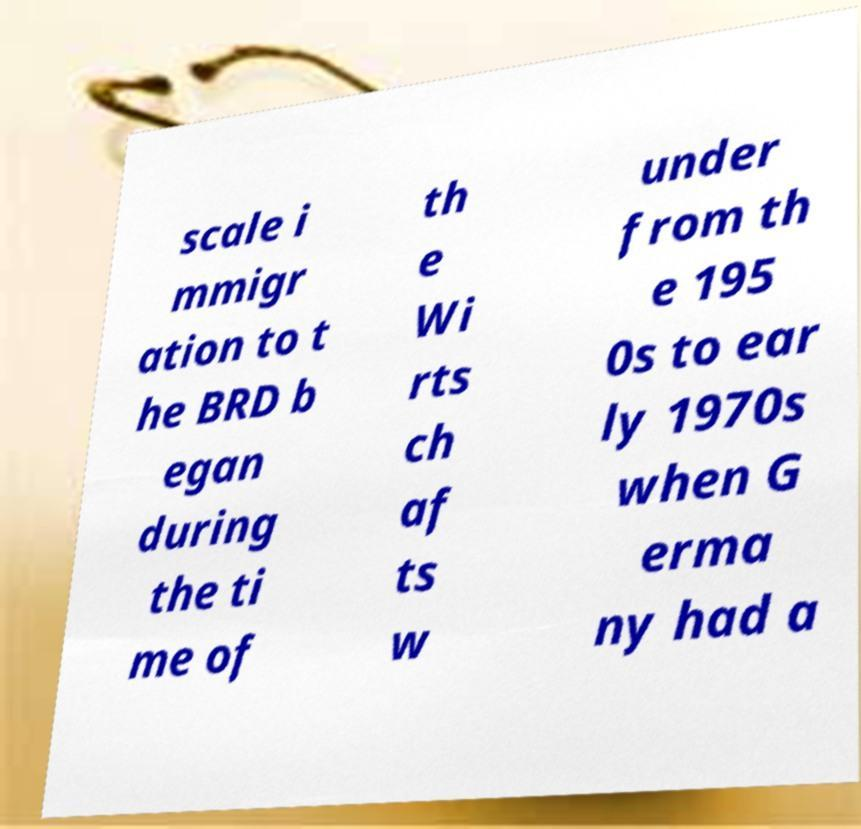Please identify and transcribe the text found in this image. scale i mmigr ation to t he BRD b egan during the ti me of th e Wi rts ch af ts w under from th e 195 0s to ear ly 1970s when G erma ny had a 